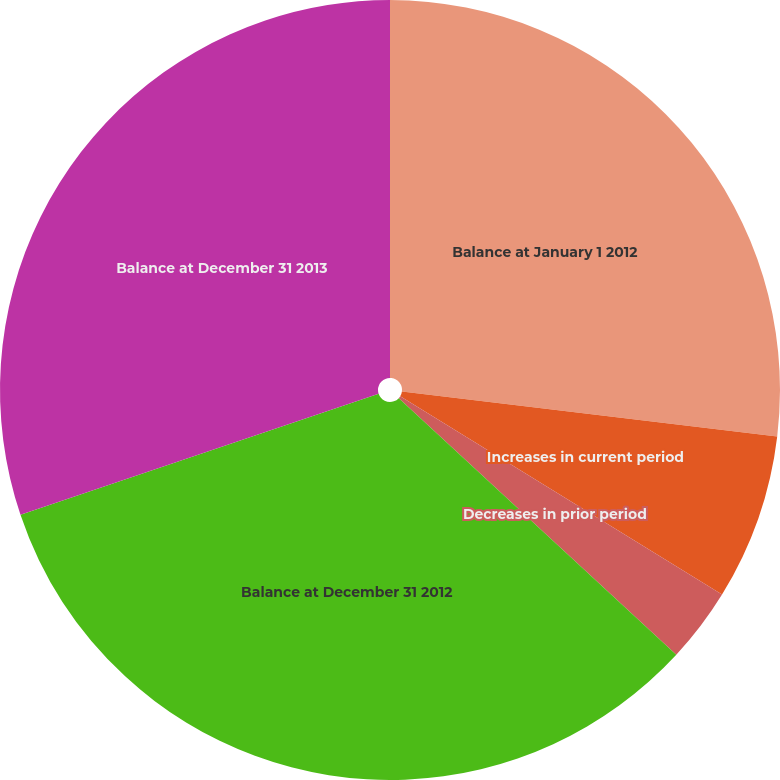<chart> <loc_0><loc_0><loc_500><loc_500><pie_chart><fcel>Balance at January 1 2012<fcel>Increases in current period<fcel>Decreases in prior period<fcel>Balance at December 31 2012<fcel>Balance at December 31 2013<nl><fcel>26.9%<fcel>6.89%<fcel>3.09%<fcel>32.94%<fcel>30.18%<nl></chart> 